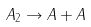<formula> <loc_0><loc_0><loc_500><loc_500>A _ { 2 } \rightarrow A + A</formula> 